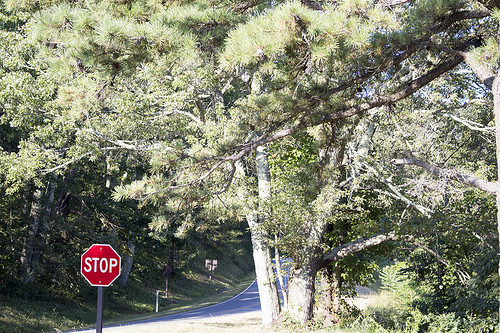<image>
Can you confirm if the tree is above the board? No. The tree is not positioned above the board. The vertical arrangement shows a different relationship. 